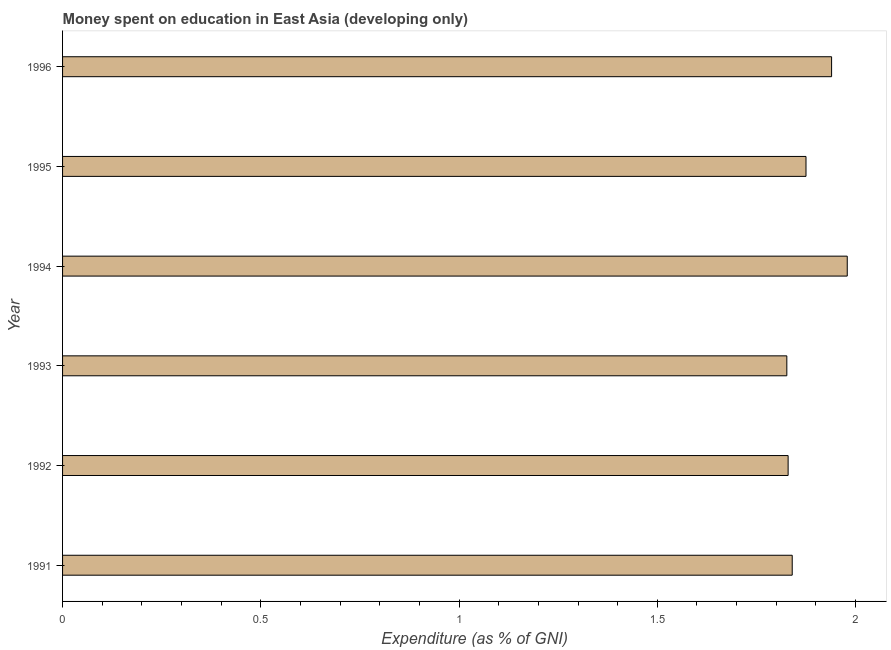Does the graph contain grids?
Your response must be concise. No. What is the title of the graph?
Provide a succinct answer. Money spent on education in East Asia (developing only). What is the label or title of the X-axis?
Provide a short and direct response. Expenditure (as % of GNI). What is the expenditure on education in 1995?
Offer a terse response. 1.87. Across all years, what is the maximum expenditure on education?
Provide a succinct answer. 1.98. Across all years, what is the minimum expenditure on education?
Ensure brevity in your answer.  1.83. What is the sum of the expenditure on education?
Provide a short and direct response. 11.29. What is the difference between the expenditure on education in 1994 and 1996?
Provide a succinct answer. 0.04. What is the average expenditure on education per year?
Offer a terse response. 1.88. What is the median expenditure on education?
Offer a terse response. 1.86. Do a majority of the years between 1993 and 1992 (inclusive) have expenditure on education greater than 1.1 %?
Your answer should be very brief. No. Is the expenditure on education in 1992 less than that in 1996?
Ensure brevity in your answer.  Yes. Is the difference between the expenditure on education in 1993 and 1994 greater than the difference between any two years?
Offer a very short reply. Yes. Is the sum of the expenditure on education in 1991 and 1996 greater than the maximum expenditure on education across all years?
Offer a very short reply. Yes. How many bars are there?
Your answer should be very brief. 6. How many years are there in the graph?
Ensure brevity in your answer.  6. What is the Expenditure (as % of GNI) of 1991?
Your answer should be very brief. 1.84. What is the Expenditure (as % of GNI) of 1992?
Make the answer very short. 1.83. What is the Expenditure (as % of GNI) in 1993?
Keep it short and to the point. 1.83. What is the Expenditure (as % of GNI) in 1994?
Provide a succinct answer. 1.98. What is the Expenditure (as % of GNI) in 1995?
Keep it short and to the point. 1.87. What is the Expenditure (as % of GNI) in 1996?
Make the answer very short. 1.94. What is the difference between the Expenditure (as % of GNI) in 1991 and 1992?
Make the answer very short. 0.01. What is the difference between the Expenditure (as % of GNI) in 1991 and 1993?
Make the answer very short. 0.01. What is the difference between the Expenditure (as % of GNI) in 1991 and 1994?
Offer a terse response. -0.14. What is the difference between the Expenditure (as % of GNI) in 1991 and 1995?
Ensure brevity in your answer.  -0.03. What is the difference between the Expenditure (as % of GNI) in 1991 and 1996?
Provide a succinct answer. -0.1. What is the difference between the Expenditure (as % of GNI) in 1992 and 1993?
Provide a short and direct response. 0. What is the difference between the Expenditure (as % of GNI) in 1992 and 1994?
Provide a short and direct response. -0.15. What is the difference between the Expenditure (as % of GNI) in 1992 and 1995?
Your answer should be compact. -0.05. What is the difference between the Expenditure (as % of GNI) in 1992 and 1996?
Keep it short and to the point. -0.11. What is the difference between the Expenditure (as % of GNI) in 1993 and 1994?
Provide a succinct answer. -0.15. What is the difference between the Expenditure (as % of GNI) in 1993 and 1995?
Give a very brief answer. -0.05. What is the difference between the Expenditure (as % of GNI) in 1993 and 1996?
Provide a succinct answer. -0.11. What is the difference between the Expenditure (as % of GNI) in 1994 and 1995?
Your answer should be compact. 0.1. What is the difference between the Expenditure (as % of GNI) in 1994 and 1996?
Provide a short and direct response. 0.04. What is the difference between the Expenditure (as % of GNI) in 1995 and 1996?
Your answer should be compact. -0.06. What is the ratio of the Expenditure (as % of GNI) in 1991 to that in 1992?
Provide a short and direct response. 1.01. What is the ratio of the Expenditure (as % of GNI) in 1991 to that in 1993?
Offer a very short reply. 1.01. What is the ratio of the Expenditure (as % of GNI) in 1991 to that in 1994?
Give a very brief answer. 0.93. What is the ratio of the Expenditure (as % of GNI) in 1991 to that in 1995?
Make the answer very short. 0.98. What is the ratio of the Expenditure (as % of GNI) in 1991 to that in 1996?
Keep it short and to the point. 0.95. What is the ratio of the Expenditure (as % of GNI) in 1992 to that in 1994?
Your response must be concise. 0.93. What is the ratio of the Expenditure (as % of GNI) in 1992 to that in 1996?
Provide a short and direct response. 0.94. What is the ratio of the Expenditure (as % of GNI) in 1993 to that in 1994?
Give a very brief answer. 0.92. What is the ratio of the Expenditure (as % of GNI) in 1993 to that in 1995?
Offer a very short reply. 0.97. What is the ratio of the Expenditure (as % of GNI) in 1993 to that in 1996?
Ensure brevity in your answer.  0.94. What is the ratio of the Expenditure (as % of GNI) in 1994 to that in 1995?
Offer a terse response. 1.05. What is the ratio of the Expenditure (as % of GNI) in 1994 to that in 1996?
Offer a terse response. 1.02. What is the ratio of the Expenditure (as % of GNI) in 1995 to that in 1996?
Give a very brief answer. 0.97. 